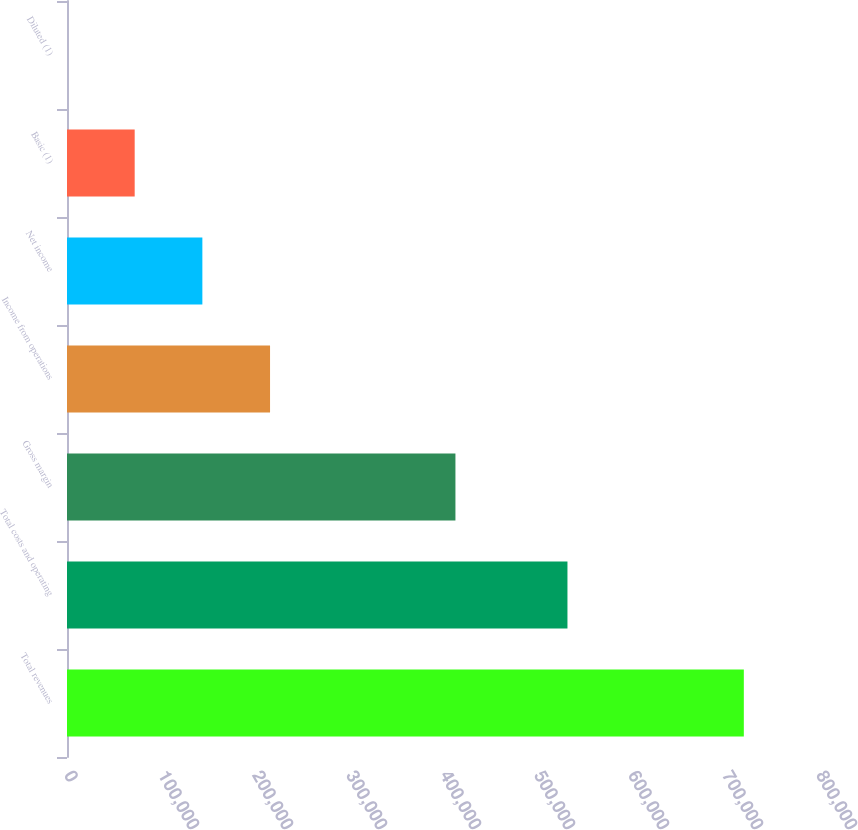Convert chart. <chart><loc_0><loc_0><loc_500><loc_500><bar_chart><fcel>Total revenues<fcel>Total costs and operating<fcel>Gross margin<fcel>Income from operations<fcel>Net income<fcel>Basic (1)<fcel>Diluted (1)<nl><fcel>720032<fcel>532397<fcel>413228<fcel>216010<fcel>144007<fcel>72003.9<fcel>0.8<nl></chart> 